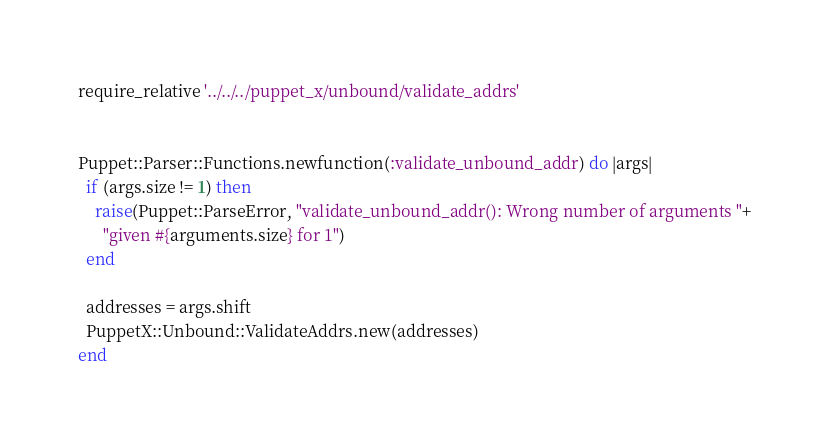Convert code to text. <code><loc_0><loc_0><loc_500><loc_500><_Ruby_>require_relative '../../../puppet_x/unbound/validate_addrs'


Puppet::Parser::Functions.newfunction(:validate_unbound_addr) do |args|
  if (args.size != 1) then
    raise(Puppet::ParseError, "validate_unbound_addr(): Wrong number of arguments "+
      "given #{arguments.size} for 1")
  end

  addresses = args.shift
  PuppetX::Unbound::ValidateAddrs.new(addresses)
end
</code> 